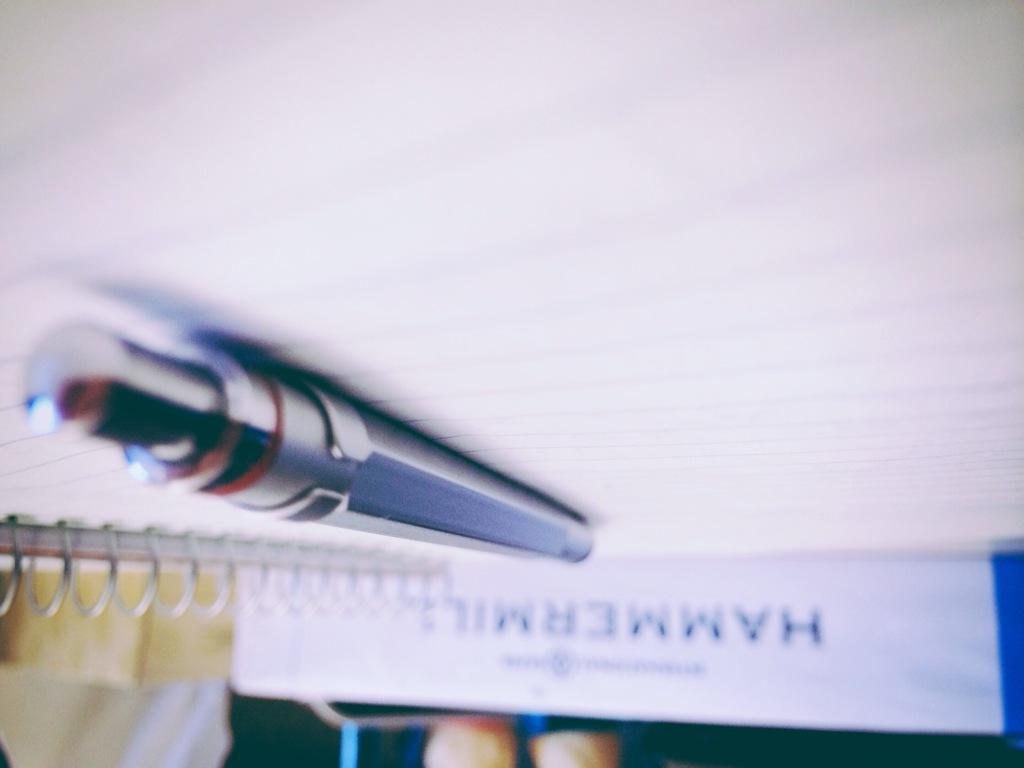How would you summarize this image in a sentence or two? In the center of the image, we can see a pen on the book and in the background, there are some other books. 